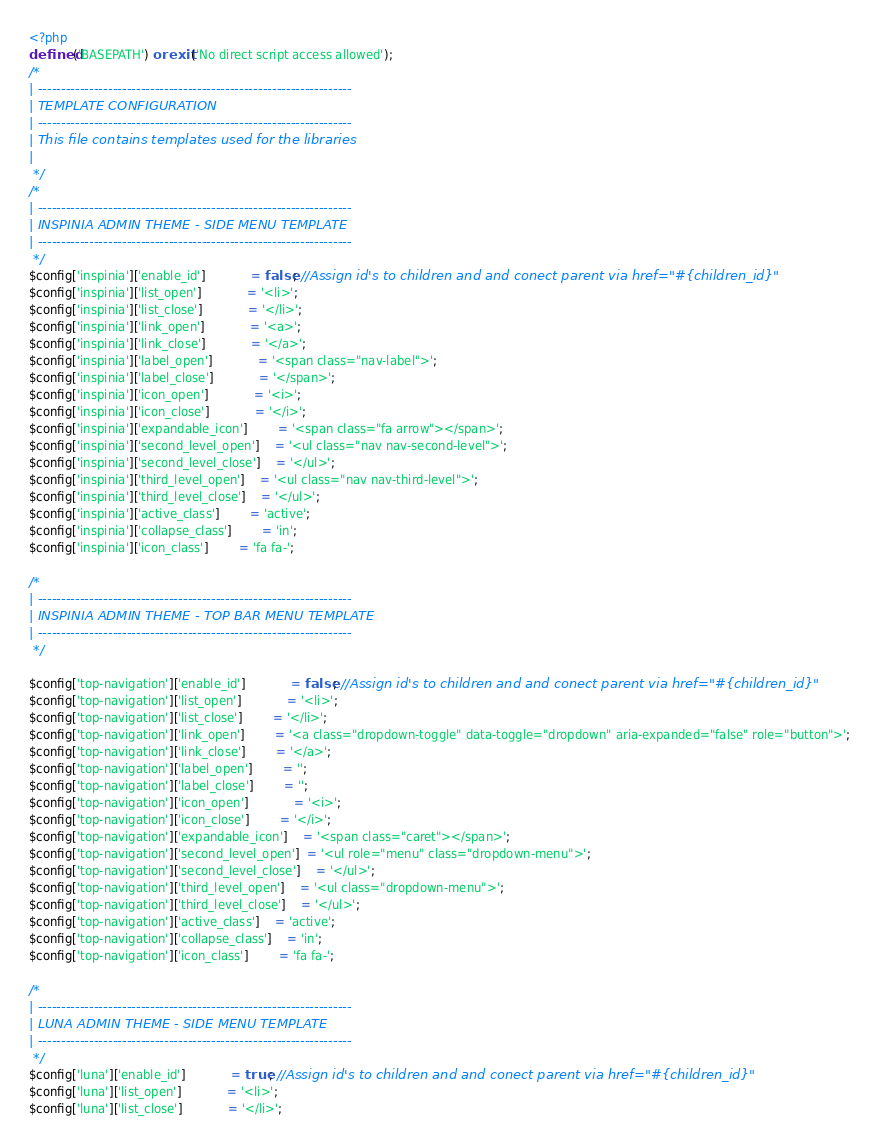Convert code to text. <code><loc_0><loc_0><loc_500><loc_500><_PHP_><?php
defined('BASEPATH') or exit('No direct script access allowed');
/*
| -------------------------------------------------------------------
| TEMPLATE CONFIGURATION
| -------------------------------------------------------------------
| This file contains templates used for the libraries
|
 */
/*
| -------------------------------------------------------------------
| INSPINIA ADMIN THEME - SIDE MENU TEMPLATE
| -------------------------------------------------------------------
 */
$config['inspinia']['enable_id'] 			= false; //Assign id's to children and and conect parent via href="#{children_id}"
$config['inspinia']['list_open'] 			= '<li>';
$config['inspinia']['list_close'] 			= '</li>';
$config['inspinia']['link_open']  			= '<a>';
$config['inspinia']['link_close'] 			= '</a>';
$config['inspinia']['label_open']  			= '<span class="nav-label">';
$config['inspinia']['label_close'] 			= '</span>';
$config['inspinia']['icon_open'] 	 		= '<i>';
$config['inspinia']['icon_close'] 	 		= '</i>';
$config['inspinia']['expandable_icon'] 		= '<span class="fa arrow"></span>';
$config['inspinia']['second_level_open']    = '<ul class="nav nav-second-level">';
$config['inspinia']['second_level_close']	= '</ul>';
$config['inspinia']['third_level_open']  	= '<ul class="nav nav-third-level">';
$config['inspinia']['third_level_close'] 	= '</ul>';
$config['inspinia']['active_class']   		= 'active';
$config['inspinia']['collapse_class'] 		= 'in';
$config['inspinia']['icon_class']   		= 'fa fa-';

/*
| -------------------------------------------------------------------
| INSPINIA ADMIN THEME - TOP BAR MENU TEMPLATE
| -------------------------------------------------------------------
 */

$config['top-navigation']['enable_id'] 			= false; //Assign id's to children and and conect parent via href="#{children_id}"
$config['top-navigation']['list_open'] 			= '<li>';
$config['top-navigation']['list_close'] 		= '</li>';
$config['top-navigation']['link_open']  		= '<a class="dropdown-toggle" data-toggle="dropdown" aria-expanded="false" role="button">';
$config['top-navigation']['link_close'] 		= '</a>';
$config['top-navigation']['label_open']  		= '';
$config['top-navigation']['label_close'] 		= '';
$config['top-navigation']['icon_open'] 	 		= '<i>';
$config['top-navigation']['icon_close'] 		= '</i>';
$config['top-navigation']['expandable_icon']	= '<span class="caret"></span>';
$config['top-navigation']['second_level_open']  = '<ul role="menu" class="dropdown-menu">';
$config['top-navigation']['second_level_close']	= '</ul>';
$config['top-navigation']['third_level_open']  	= '<ul class="dropdown-menu">';
$config['top-navigation']['third_level_close'] 	= '</ul>';
$config['top-navigation']['active_class']   	= 'active';
$config['top-navigation']['collapse_class'] 	= 'in';
$config['top-navigation']['icon_class']   		= 'fa fa-';

/*
| -------------------------------------------------------------------
| LUNA ADMIN THEME - SIDE MENU TEMPLATE
| -------------------------------------------------------------------
 */
$config['luna']['enable_id'] 			= true; //Assign id's to children and and conect parent via href="#{children_id}"
$config['luna']['list_open'] 			= '<li>';
$config['luna']['list_close'] 			= '</li>';</code> 